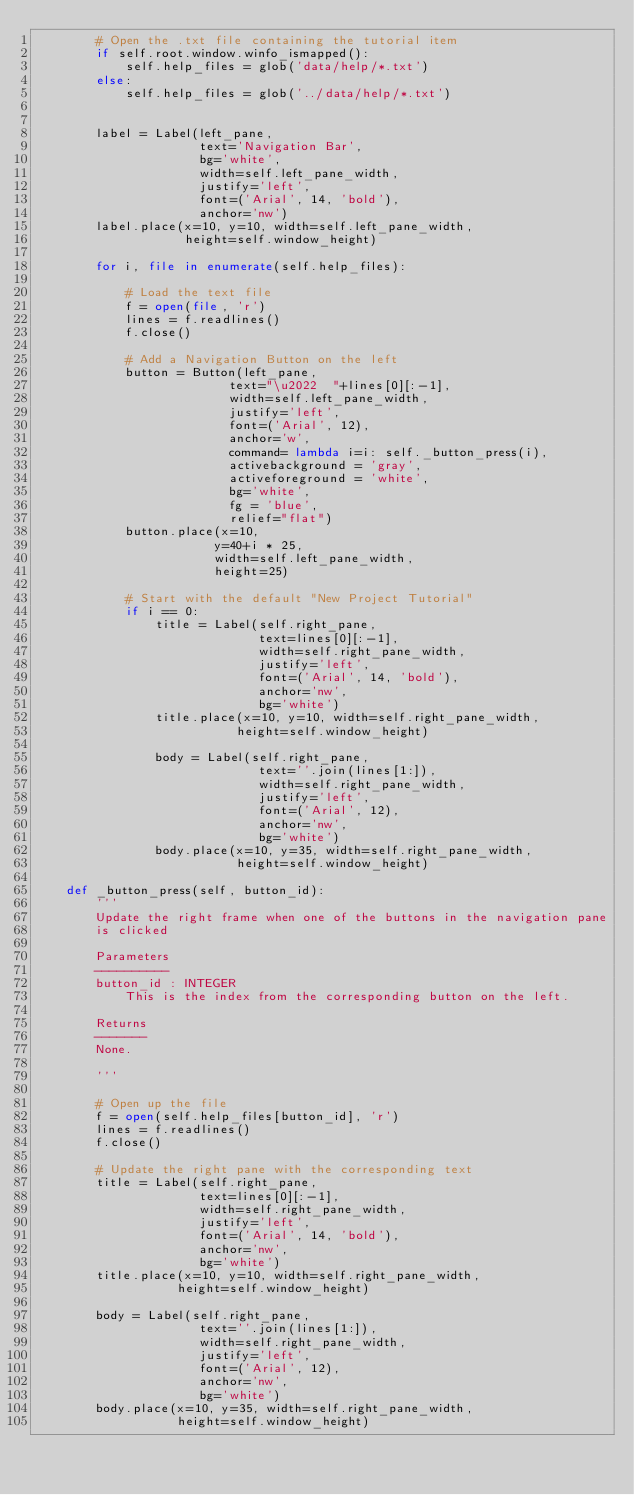Convert code to text. <code><loc_0><loc_0><loc_500><loc_500><_Python_>        # Open the .txt file containing the tutorial item
        if self.root.window.winfo_ismapped():
            self.help_files = glob('data/help/*.txt')
        else:
            self.help_files = glob('../data/help/*.txt')
           
        
        label = Label(left_pane, 
                      text='Navigation Bar', 
                      bg='white', 
                      width=self.left_pane_width,
                      justify='left',
                      font=('Arial', 14, 'bold'),
                      anchor='nw')
        label.place(x=10, y=10, width=self.left_pane_width, 
                    height=self.window_height)
        
        for i, file in enumerate(self.help_files):
            
            # Load the text file
            f = open(file, 'r')
            lines = f.readlines()
            f.close()
            
            # Add a Navigation Button on the left
            button = Button(left_pane, 
                          text="\u2022  "+lines[0][:-1],
                          width=self.left_pane_width, 
                          justify='left',
                          font=('Arial', 12),
                          anchor='w',
                          command= lambda i=i: self._button_press(i),
                          activebackground = 'gray',
                          activeforeground = 'white',
                          bg='white',
                          fg = 'blue',
                          relief="flat")
            button.place(x=10, 
                        y=40+i * 25,
                        width=self.left_pane_width,
                        height=25)
            
            # Start with the default "New Project Tutorial"
            if i == 0:
                title = Label(self.right_pane, 
                              text=lines[0][:-1],
                              width=self.right_pane_width, 
                              justify='left',
                              font=('Arial', 14, 'bold'),
                              anchor='nw',
                              bg='white')
                title.place(x=10, y=10, width=self.right_pane_width, 
                           height=self.window_height)
                
                body = Label(self.right_pane, 
                              text=''.join(lines[1:]),
                              width=self.right_pane_width, 
                              justify='left',
                              font=('Arial', 12),
                              anchor='nw',
                              bg='white')
                body.place(x=10, y=35, width=self.right_pane_width, 
                           height=self.window_height)
            
    def _button_press(self, button_id):
        '''
        Update the right frame when one of the buttons in the navigation pane
        is clicked

        Parameters
        ----------
        button_id : INTEGER
            This is the index from the corresponding button on the left.

        Returns
        -------
        None.

        '''
        
        # Open up the file
        f = open(self.help_files[button_id], 'r')
        lines = f.readlines()
        f.close()        

        # Update the right pane with the corresponding text
        title = Label(self.right_pane, 
                      text=lines[0][:-1],
                      width=self.right_pane_width, 
                      justify='left',
                      font=('Arial', 14, 'bold'),
                      anchor='nw',
                      bg='white')
        title.place(x=10, y=10, width=self.right_pane_width, 
                   height=self.window_height)
        
        body = Label(self.right_pane, 
                      text=''.join(lines[1:]),
                      width=self.right_pane_width, 
                      justify='left',
                      font=('Arial', 12),
                      anchor='nw',
                      bg='white')
        body.place(x=10, y=35, width=self.right_pane_width, 
                   height=self.window_height)
         </code> 